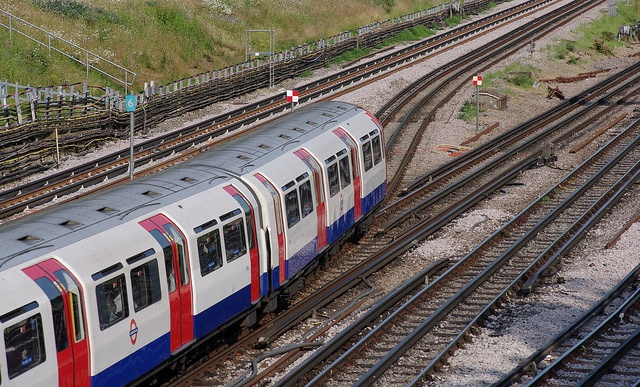Describe the objects in this image and their specific colors. I can see a train in olive, darkgray, black, lightgray, and gray tones in this image. 